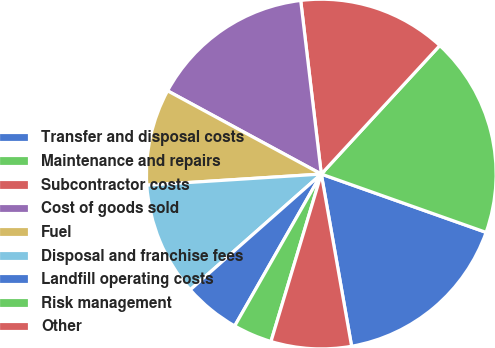Convert chart. <chart><loc_0><loc_0><loc_500><loc_500><pie_chart><fcel>Transfer and disposal costs<fcel>Maintenance and repairs<fcel>Subcontractor costs<fcel>Cost of goods sold<fcel>Fuel<fcel>Disposal and franchise fees<fcel>Landfill operating costs<fcel>Risk management<fcel>Other<nl><fcel>16.81%<fcel>18.56%<fcel>13.73%<fcel>15.22%<fcel>8.91%<fcel>10.5%<fcel>5.24%<fcel>3.6%<fcel>7.42%<nl></chart> 